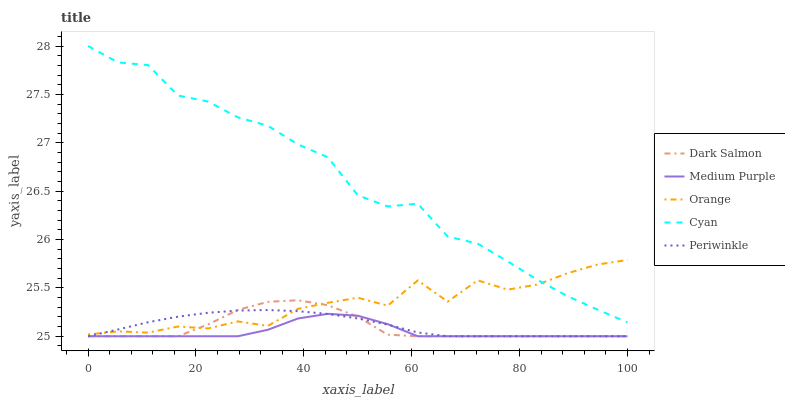Does Medium Purple have the minimum area under the curve?
Answer yes or no. Yes. Does Cyan have the maximum area under the curve?
Answer yes or no. Yes. Does Orange have the minimum area under the curve?
Answer yes or no. No. Does Orange have the maximum area under the curve?
Answer yes or no. No. Is Periwinkle the smoothest?
Answer yes or no. Yes. Is Orange the roughest?
Answer yes or no. Yes. Is Orange the smoothest?
Answer yes or no. No. Is Periwinkle the roughest?
Answer yes or no. No. Does Medium Purple have the lowest value?
Answer yes or no. Yes. Does Orange have the lowest value?
Answer yes or no. No. Does Cyan have the highest value?
Answer yes or no. Yes. Does Orange have the highest value?
Answer yes or no. No. Is Medium Purple less than Cyan?
Answer yes or no. Yes. Is Cyan greater than Periwinkle?
Answer yes or no. Yes. Does Cyan intersect Orange?
Answer yes or no. Yes. Is Cyan less than Orange?
Answer yes or no. No. Is Cyan greater than Orange?
Answer yes or no. No. Does Medium Purple intersect Cyan?
Answer yes or no. No. 